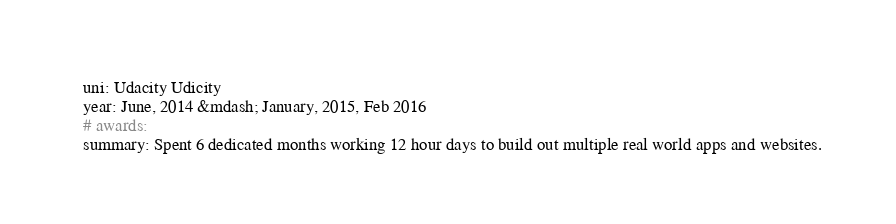Convert code to text. <code><loc_0><loc_0><loc_500><loc_500><_YAML_>  uni: Udacity Udicity
  year: June, 2014 &mdash; January, 2015, Feb 2016
  # awards:
  summary: Spent 6 dedicated months working 12 hour days to build out multiple real world apps and websites.
</code> 